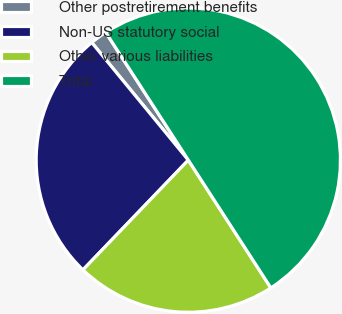Convert chart. <chart><loc_0><loc_0><loc_500><loc_500><pie_chart><fcel>Other postretirement benefits<fcel>Non-US statutory social<fcel>Other various liabilities<fcel>Total<nl><fcel>1.81%<fcel>26.88%<fcel>21.3%<fcel>50.0%<nl></chart> 